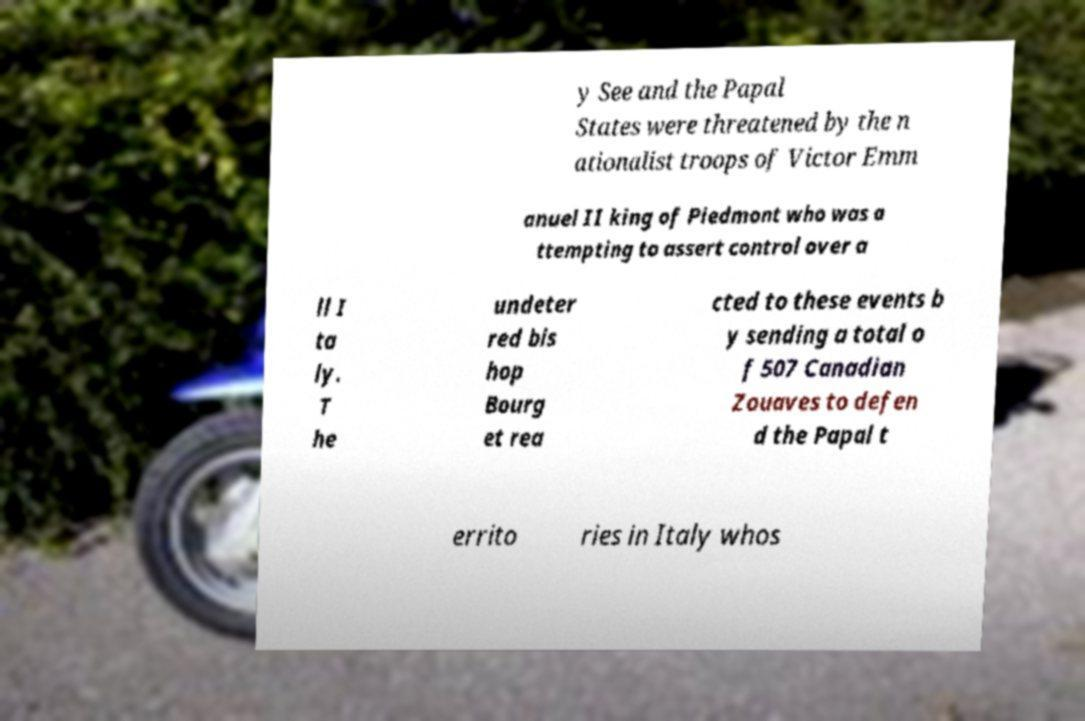I need the written content from this picture converted into text. Can you do that? y See and the Papal States were threatened by the n ationalist troops of Victor Emm anuel II king of Piedmont who was a ttempting to assert control over a ll I ta ly. T he undeter red bis hop Bourg et rea cted to these events b y sending a total o f 507 Canadian Zouaves to defen d the Papal t errito ries in Italy whos 